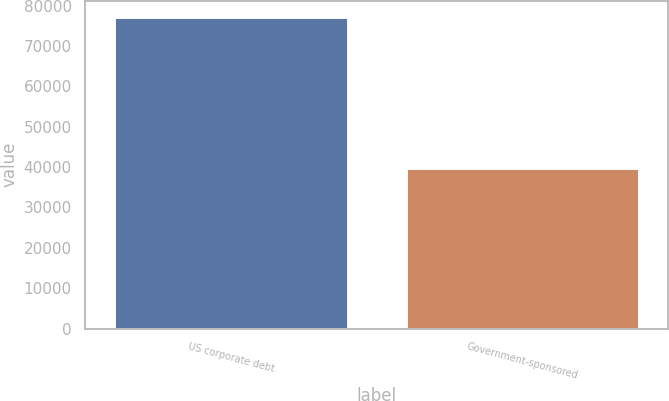Convert chart to OTSL. <chart><loc_0><loc_0><loc_500><loc_500><bar_chart><fcel>US corporate debt<fcel>Government-sponsored<nl><fcel>77281<fcel>39763<nl></chart> 